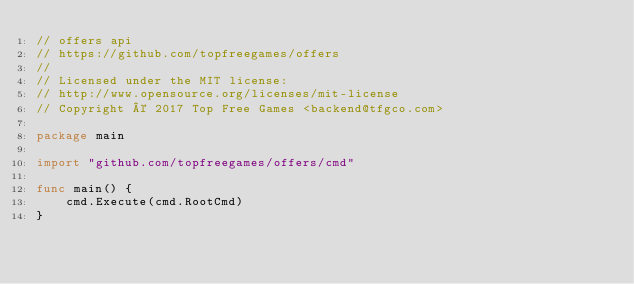Convert code to text. <code><loc_0><loc_0><loc_500><loc_500><_Go_>// offers api
// https://github.com/topfreegames/offers
//
// Licensed under the MIT license:
// http://www.opensource.org/licenses/mit-license
// Copyright © 2017 Top Free Games <backend@tfgco.com>

package main

import "github.com/topfreegames/offers/cmd"

func main() {
	cmd.Execute(cmd.RootCmd)
}
</code> 